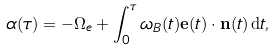Convert formula to latex. <formula><loc_0><loc_0><loc_500><loc_500>\alpha ( \tau ) = - \Omega _ { e } + \int _ { 0 } ^ { \tau } \omega _ { B } ( t ) \mathbf e ( t ) \cdot \mathbf n ( t ) \, \mathrm d t ,</formula> 